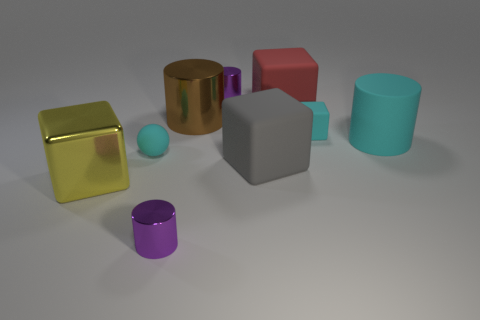Subtract 1 cylinders. How many cylinders are left? 3 Add 1 metallic balls. How many objects exist? 10 Subtract all cylinders. How many objects are left? 5 Subtract 0 brown spheres. How many objects are left? 9 Subtract all red blocks. Subtract all small spheres. How many objects are left? 7 Add 5 large yellow metal objects. How many large yellow metal objects are left? 6 Add 9 tiny gray shiny balls. How many tiny gray shiny balls exist? 9 